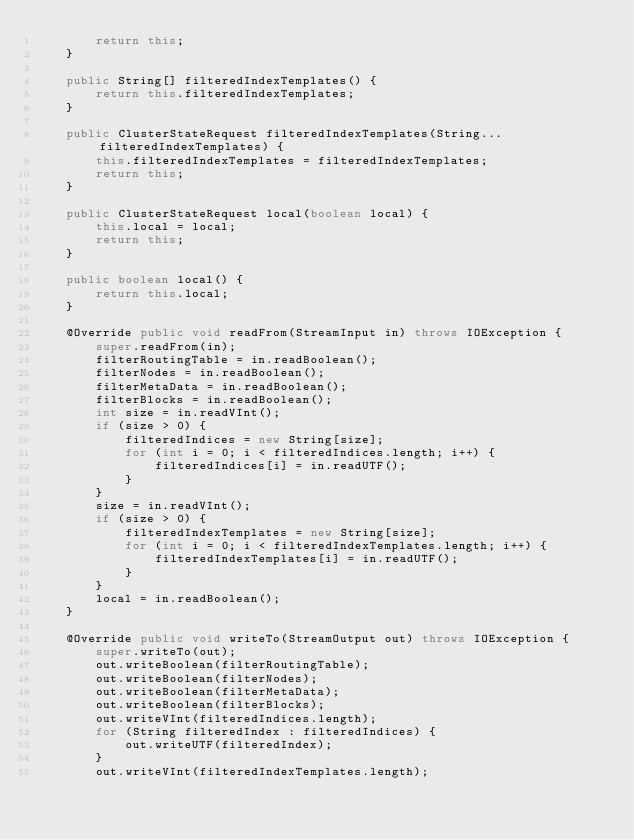<code> <loc_0><loc_0><loc_500><loc_500><_Java_>        return this;
    }

    public String[] filteredIndexTemplates() {
        return this.filteredIndexTemplates;
    }

    public ClusterStateRequest filteredIndexTemplates(String... filteredIndexTemplates) {
        this.filteredIndexTemplates = filteredIndexTemplates;
        return this;
    }

    public ClusterStateRequest local(boolean local) {
        this.local = local;
        return this;
    }

    public boolean local() {
        return this.local;
    }

    @Override public void readFrom(StreamInput in) throws IOException {
        super.readFrom(in);
        filterRoutingTable = in.readBoolean();
        filterNodes = in.readBoolean();
        filterMetaData = in.readBoolean();
        filterBlocks = in.readBoolean();
        int size = in.readVInt();
        if (size > 0) {
            filteredIndices = new String[size];
            for (int i = 0; i < filteredIndices.length; i++) {
                filteredIndices[i] = in.readUTF();
            }
        }
        size = in.readVInt();
        if (size > 0) {
            filteredIndexTemplates = new String[size];
            for (int i = 0; i < filteredIndexTemplates.length; i++) {
                filteredIndexTemplates[i] = in.readUTF();
            }
        }
        local = in.readBoolean();
    }

    @Override public void writeTo(StreamOutput out) throws IOException {
        super.writeTo(out);
        out.writeBoolean(filterRoutingTable);
        out.writeBoolean(filterNodes);
        out.writeBoolean(filterMetaData);
        out.writeBoolean(filterBlocks);
        out.writeVInt(filteredIndices.length);
        for (String filteredIndex : filteredIndices) {
            out.writeUTF(filteredIndex);
        }
        out.writeVInt(filteredIndexTemplates.length);</code> 